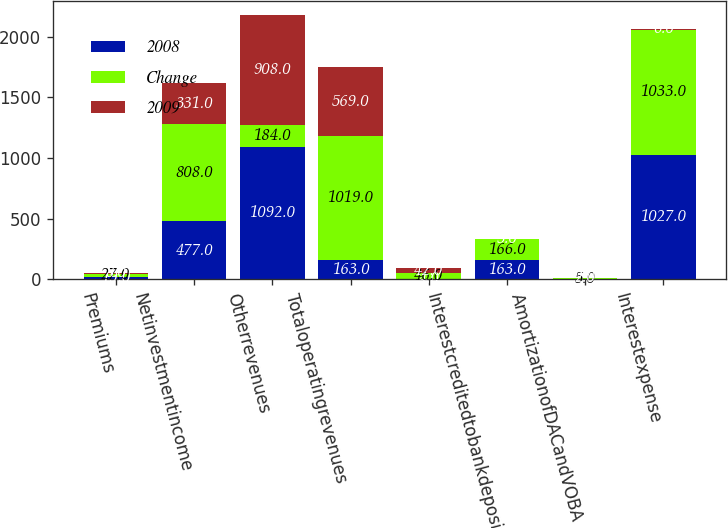Convert chart to OTSL. <chart><loc_0><loc_0><loc_500><loc_500><stacked_bar_chart><ecel><fcel>Premiums<fcel>Netinvestmentincome<fcel>Otherrevenues<fcel>Totaloperatingrevenues<fcel>Unnamed: 5<fcel>Interestcreditedtobankdeposits<fcel>AmortizationofDACandVOBA<fcel>Interestexpense<nl><fcel>2008<fcel>19<fcel>477<fcel>1092<fcel>163<fcel>4<fcel>163<fcel>3<fcel>1027<nl><fcel>Change<fcel>27<fcel>808<fcel>184<fcel>1019<fcel>46<fcel>166<fcel>5<fcel>1033<nl><fcel>2009<fcel>8<fcel>331<fcel>908<fcel>569<fcel>42<fcel>3<fcel>2<fcel>6<nl></chart> 